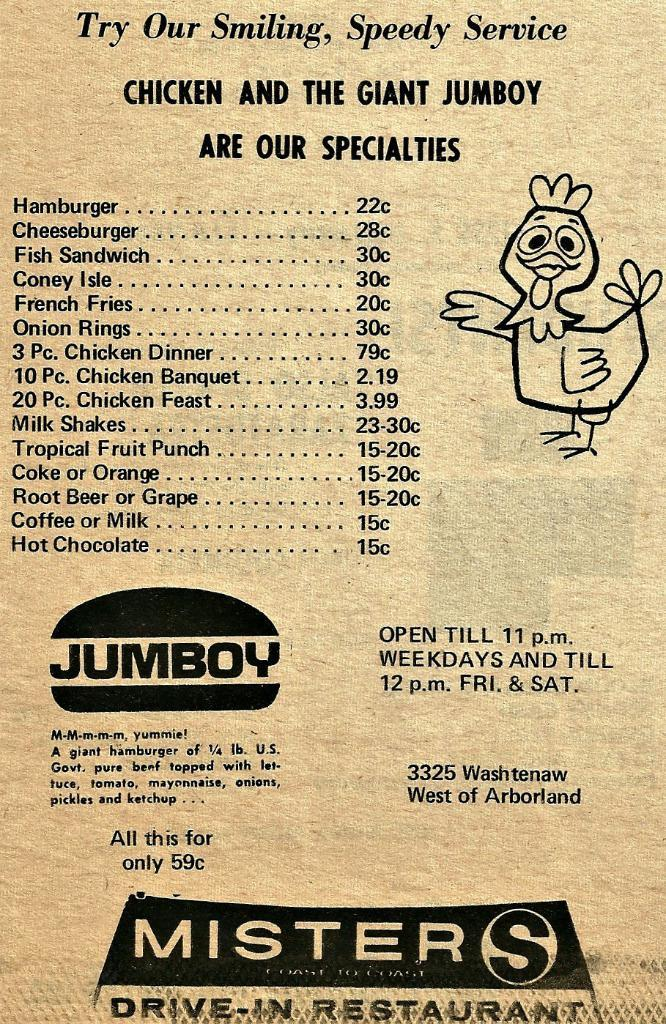<image>
Provide a brief description of the given image. A menu with a chicken on it and also has the word JUMBOY on it. 